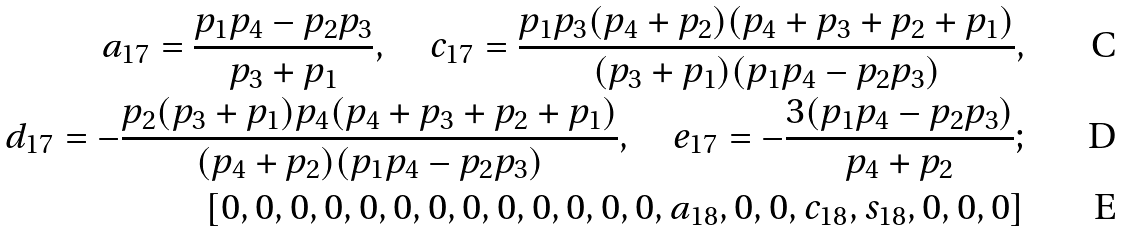<formula> <loc_0><loc_0><loc_500><loc_500>a _ { 1 7 } = \frac { p _ { 1 } p _ { 4 } - p _ { 2 } p _ { 3 } } { p _ { 3 } + p _ { 1 } } , \quad c _ { 1 7 } = \frac { p _ { 1 } p _ { 3 } ( p _ { 4 } + p _ { 2 } ) ( p _ { 4 } + p _ { 3 } + p _ { 2 } + p _ { 1 } ) } { ( p _ { 3 } + p _ { 1 } ) ( p _ { 1 } p _ { 4 } - p _ { 2 } p _ { 3 } ) } , \\ d _ { 1 7 } = - \frac { p _ { 2 } ( p _ { 3 } + p _ { 1 } ) p _ { 4 } ( p _ { 4 } + p _ { 3 } + p _ { 2 } + p _ { 1 } ) } { ( p _ { 4 } + p _ { 2 } ) ( p _ { 1 } p _ { 4 } - p _ { 2 } p _ { 3 } ) } , \quad e _ { 1 7 } = - \frac { 3 ( p _ { 1 } p _ { 4 } - p _ { 2 } p _ { 3 } ) } { p _ { 4 } + p _ { 2 } } ; \\ [ 0 , 0 , 0 , 0 , 0 , 0 , 0 , 0 , 0 , 0 , 0 , 0 , 0 , a _ { 1 8 } , 0 , 0 , c _ { 1 8 } , s _ { 1 8 } , 0 , 0 , 0 ]</formula> 